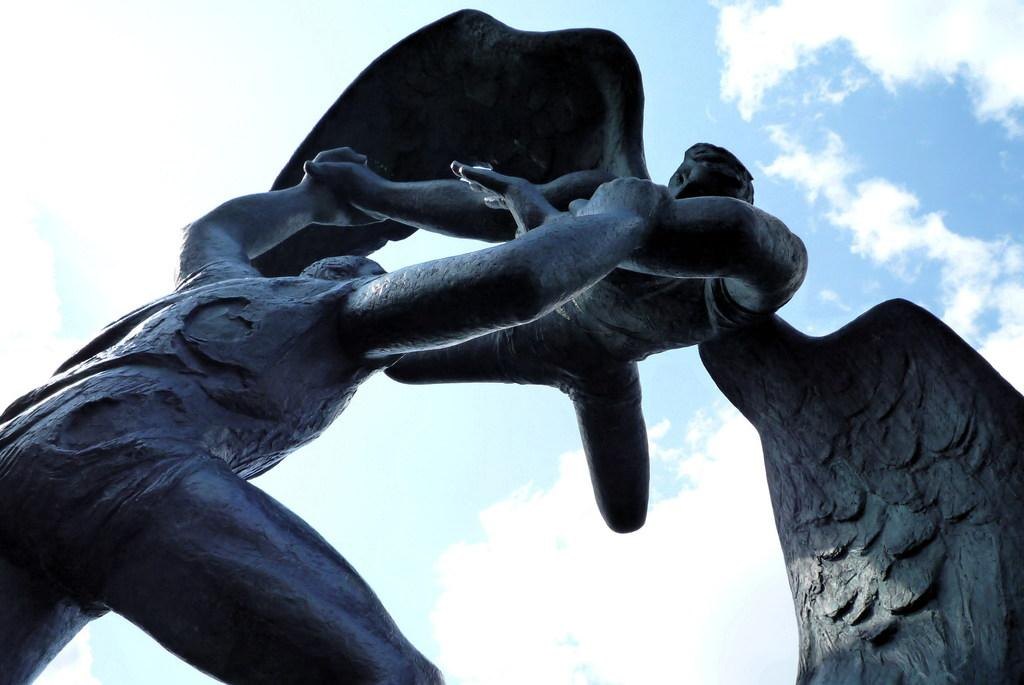What is the main subject of the image? There is a statue of a person in the image. What is the statue depicting the person doing? The statue depicts a person holding another person. What is unique about the person being held? The person being held has wings. What can be seen in the background of the image? The sky is visible in the image. What is the condition of the sky in the image? The sky has clouds. What holiday is being celebrated in the image? There is no indication of a holiday being celebrated in the image. What type of hook can be seen attached to the thumb of the person being held? There is no hook or thumb present in the image; the person being held has wings. 